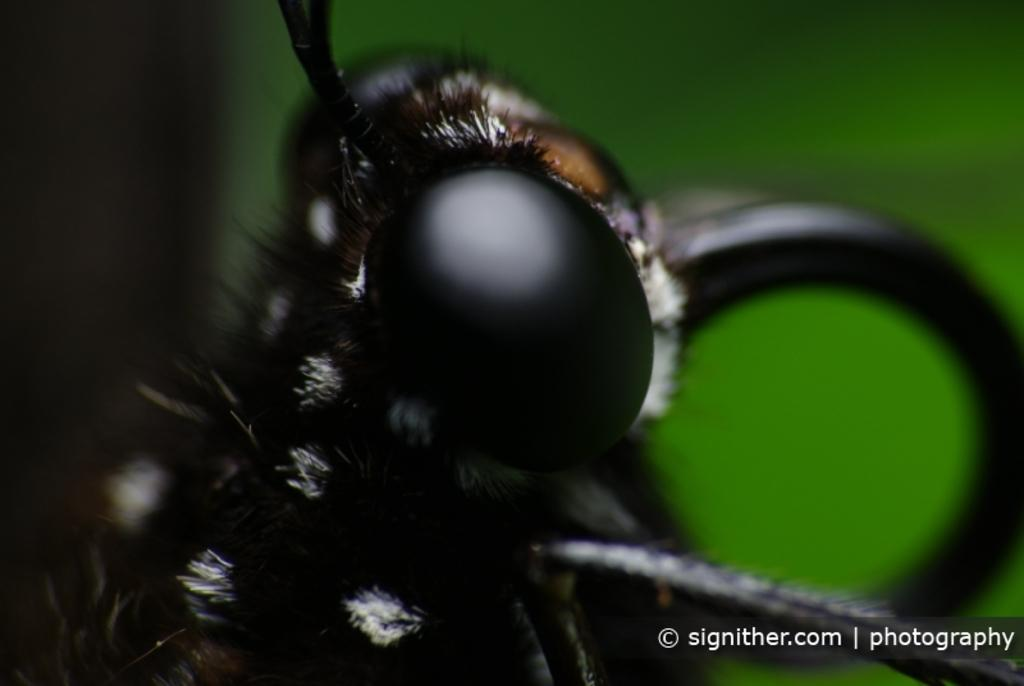What type of creature can be seen in the image? There is an insect in the image. What type of straw is the insect using to answer the question in the image? There is no straw or question present in the image; it only features an insect. 